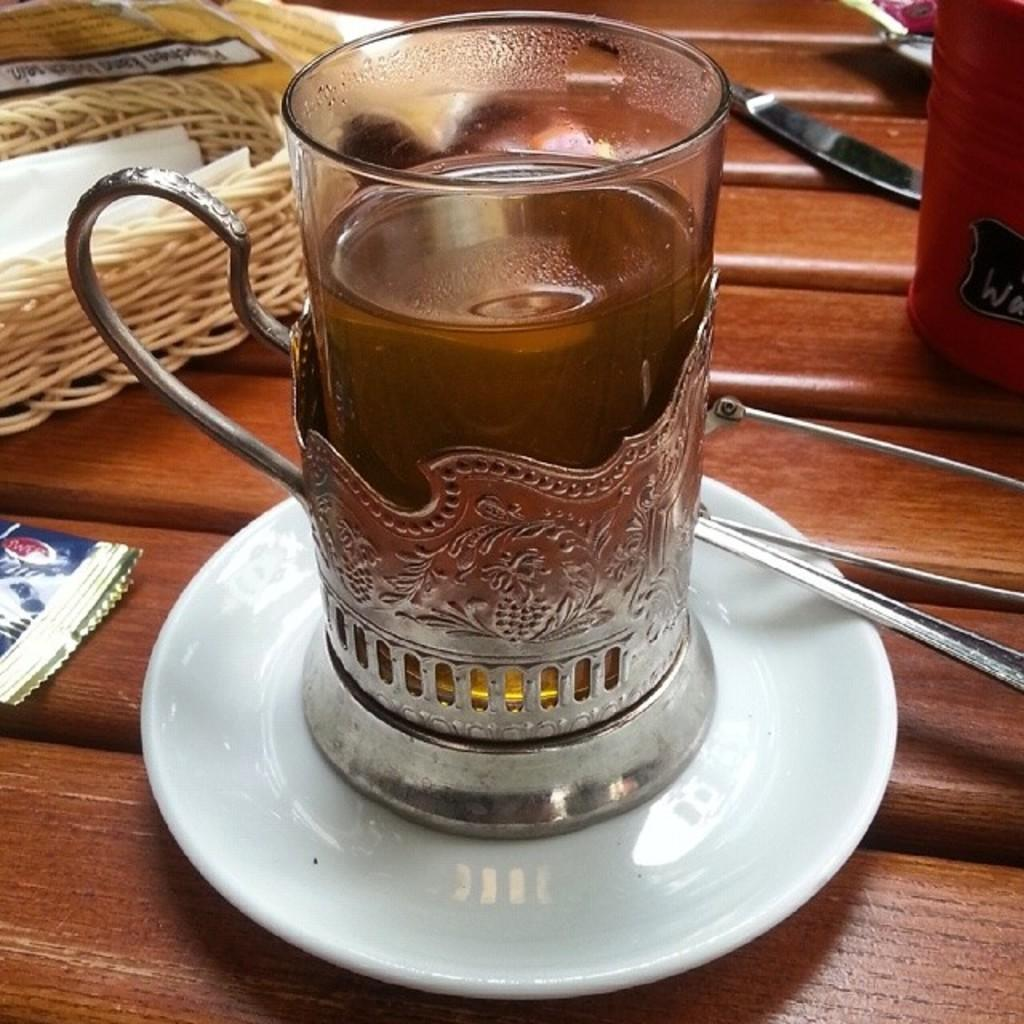What is in the glass that is visible in the image? There is a drink in the glass in the image. How is the glass positioned in the image? The glass is placed on a saucer. What utensil can be seen in the image? There is a knife in the image. What type of container is holding tissues in the image? There is a basket with tissues in the image. What type of stitch is being used to sew the carriage in the image? There is no carriage or stitching present in the image. 